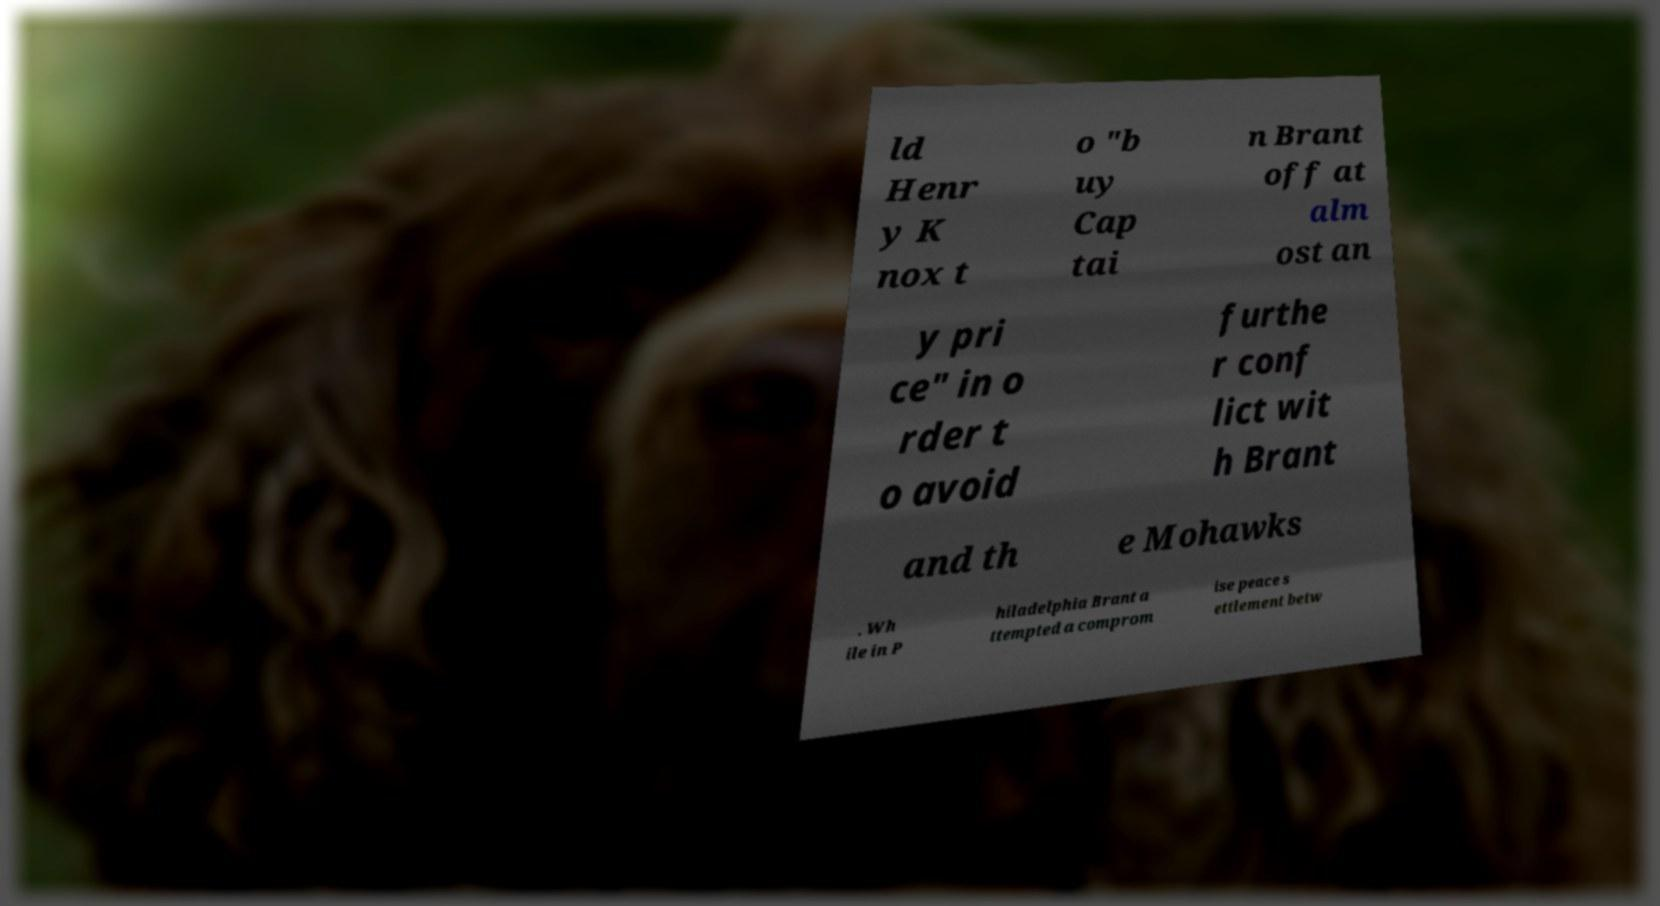Please read and relay the text visible in this image. What does it say? ld Henr y K nox t o "b uy Cap tai n Brant off at alm ost an y pri ce" in o rder t o avoid furthe r conf lict wit h Brant and th e Mohawks . Wh ile in P hiladelphia Brant a ttempted a comprom ise peace s ettlement betw 